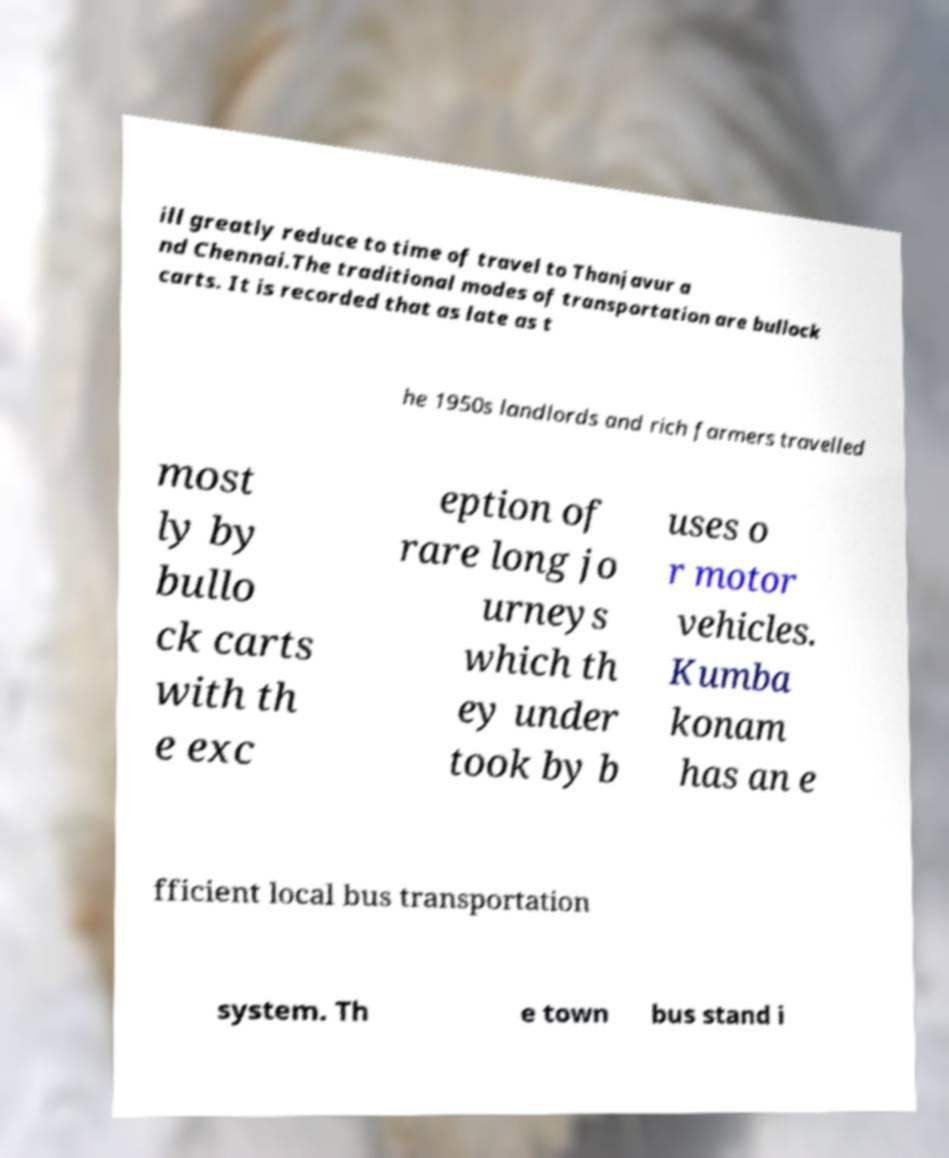Can you accurately transcribe the text from the provided image for me? ill greatly reduce to time of travel to Thanjavur a nd Chennai.The traditional modes of transportation are bullock carts. It is recorded that as late as t he 1950s landlords and rich farmers travelled most ly by bullo ck carts with th e exc eption of rare long jo urneys which th ey under took by b uses o r motor vehicles. Kumba konam has an e fficient local bus transportation system. Th e town bus stand i 